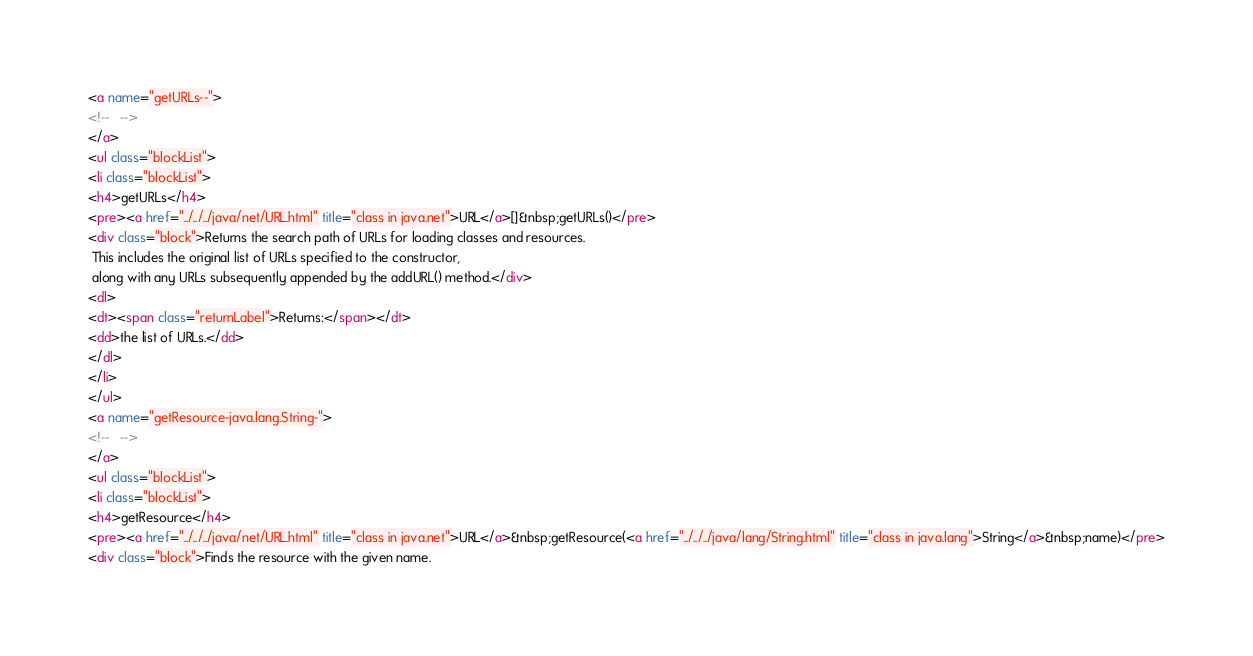Convert code to text. <code><loc_0><loc_0><loc_500><loc_500><_HTML_><a name="getURLs--">
<!--   -->
</a>
<ul class="blockList">
<li class="blockList">
<h4>getURLs</h4>
<pre><a href="../../../java/net/URL.html" title="class in java.net">URL</a>[]&nbsp;getURLs()</pre>
<div class="block">Returns the search path of URLs for loading classes and resources.
 This includes the original list of URLs specified to the constructor,
 along with any URLs subsequently appended by the addURL() method.</div>
<dl>
<dt><span class="returnLabel">Returns:</span></dt>
<dd>the list of URLs.</dd>
</dl>
</li>
</ul>
<a name="getResource-java.lang.String-">
<!--   -->
</a>
<ul class="blockList">
<li class="blockList">
<h4>getResource</h4>
<pre><a href="../../../java/net/URL.html" title="class in java.net">URL</a>&nbsp;getResource(<a href="../../../java/lang/String.html" title="class in java.lang">String</a>&nbsp;name)</pre>
<div class="block">Finds the resource with the given name.</code> 